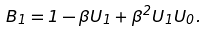<formula> <loc_0><loc_0><loc_500><loc_500>B _ { 1 } = 1 - \beta U _ { 1 } + \beta ^ { 2 } U _ { 1 } U _ { 0 } .</formula> 